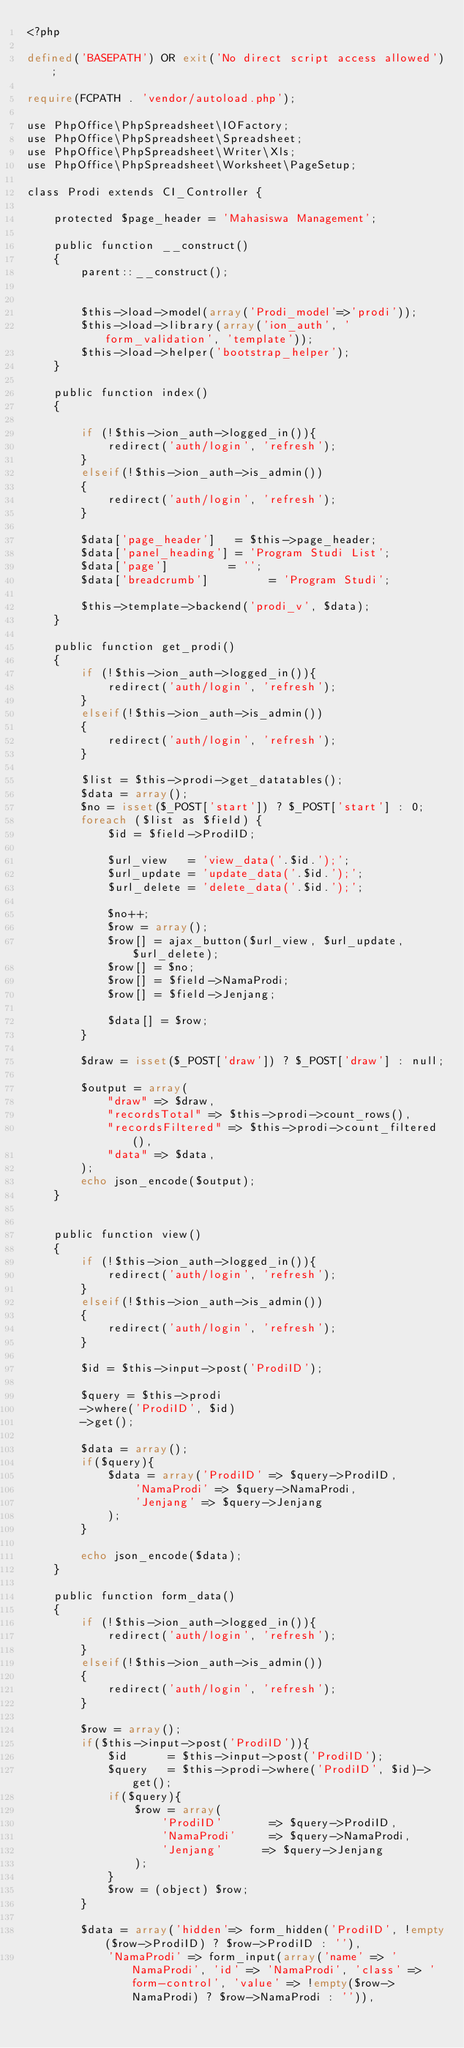<code> <loc_0><loc_0><loc_500><loc_500><_PHP_><?php

defined('BASEPATH') OR exit('No direct script access allowed');

require(FCPATH . 'vendor/autoload.php');

use PhpOffice\PhpSpreadsheet\IOFactory;
use PhpOffice\PhpSpreadsheet\Spreadsheet;
use PhpOffice\PhpSpreadsheet\Writer\Xls;
use PhpOffice\PhpSpreadsheet\Worksheet\PageSetup;

class Prodi extends CI_Controller {

	protected $page_header = 'Mahasiswa Management';

	public function __construct()
	{
		parent::__construct();


		$this->load->model(array('Prodi_model'=>'prodi'));
		$this->load->library(array('ion_auth', 'form_validation', 'template'));
		$this->load->helper('bootstrap_helper');
	}

	public function index()
	{  
		
		if (!$this->ion_auth->logged_in()){            
			redirect('auth/login', 'refresh');
		}
		elseif(!$this->ion_auth->is_admin()) 
		{
			redirect('auth/login', 'refresh');
		}

		$data['page_header']   = $this->page_header;
		$data['panel_heading'] = 'Program Studi List';
		$data['page']         = '';
		$data['breadcrumb']         = 'Program Studi';

		$this->template->backend('prodi_v', $data);
	}

	public function get_prodi()
	{
		if (!$this->ion_auth->logged_in()){            
			redirect('auth/login', 'refresh');
		}
		elseif(!$this->ion_auth->is_admin()) 
		{
			redirect('auth/login', 'refresh');
		}

		$list = $this->prodi->get_datatables();
		$data = array();
		$no = isset($_POST['start']) ? $_POST['start'] : 0;
		foreach ($list as $field) { 
			$id = $field->ProdiID;

			$url_view   = 'view_data('.$id.');';
			$url_update = 'update_data('.$id.');';
			$url_delete = 'delete_data('.$id.');';

			$no++;
			$row = array();
			$row[] = ajax_button($url_view, $url_update, $url_delete);
			$row[] = $no;
			$row[] = $field->NamaProdi;
			$row[] = $field->Jenjang;

			$data[] = $row;
		}
		
		$draw = isset($_POST['draw']) ? $_POST['draw'] : null;

		$output = array(
			"draw" => $draw,
			"recordsTotal" => $this->prodi->count_rows(),
			"recordsFiltered" => $this->prodi->count_filtered(),
			"data" => $data,
		);
		echo json_encode($output);
	}


	public function view()
	{
		if (!$this->ion_auth->logged_in()){            
			redirect('auth/login', 'refresh');
		}
		elseif(!$this->ion_auth->is_admin()) 
		{
			redirect('auth/login', 'refresh');
		}

		$id = $this->input->post('ProdiID');

		$query = $this->prodi
		->where('ProdiID', $id)
		->get();

		$data = array();
		if($query){
			$data = array('ProdiID' => $query->ProdiID,
				'NamaProdi' => $query->NamaProdi,
				'Jenjang' => $query->Jenjang
			);
		}

		echo json_encode($data);
	}

	public function form_data()
	{
		if (!$this->ion_auth->logged_in()){            
			redirect('auth/login', 'refresh');
		}
		elseif(!$this->ion_auth->is_admin()) 
		{
			redirect('auth/login', 'refresh');
		}

		$row = array();
		if($this->input->post('ProdiID')){
			$id      = $this->input->post('ProdiID');
			$query   = $this->prodi->where('ProdiID', $id)->get(); 
			if($query){
				$row = array(
					'ProdiID'       => $query->ProdiID,
					'NamaProdi'     => $query->NamaProdi,
					'Jenjang'      => $query->Jenjang
				);
			}
			$row = (object) $row;
		}

		$data = array('hidden'=> form_hidden('ProdiID', !empty($row->ProdiID) ? $row->ProdiID : ''),
			'NamaProdi' => form_input(array('name' => 'NamaProdi', 'id' => 'NamaProdi', 'class' => 'form-control', 'value' => !empty($row->NamaProdi) ? $row->NamaProdi : '')),</code> 